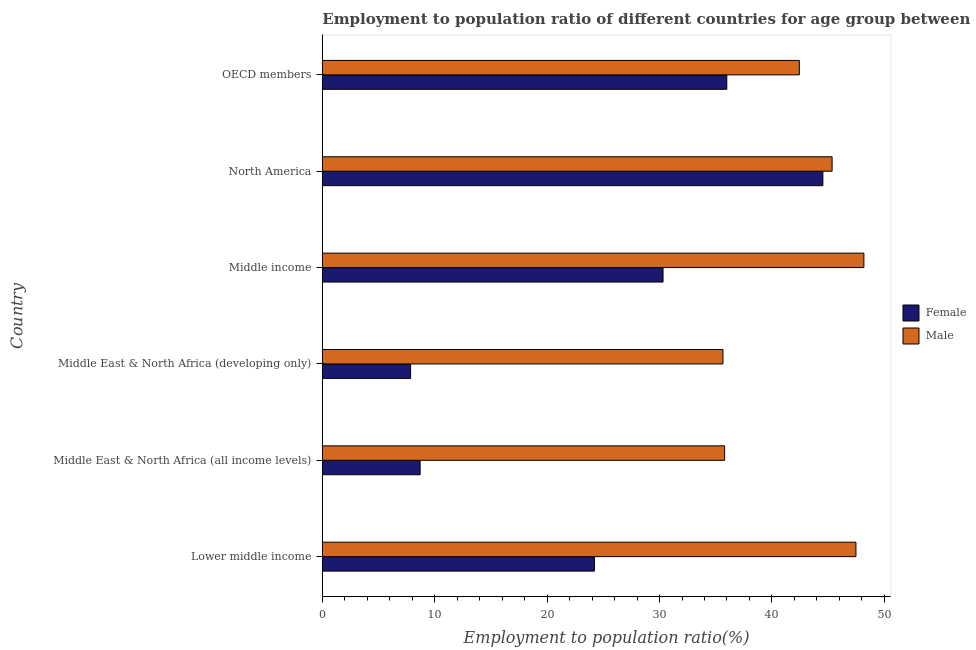How many different coloured bars are there?
Keep it short and to the point. 2. Are the number of bars per tick equal to the number of legend labels?
Offer a very short reply. Yes. Are the number of bars on each tick of the Y-axis equal?
Your response must be concise. Yes. How many bars are there on the 2nd tick from the top?
Offer a terse response. 2. How many bars are there on the 5th tick from the bottom?
Provide a succinct answer. 2. What is the label of the 3rd group of bars from the top?
Give a very brief answer. Middle income. What is the employment to population ratio(female) in Middle income?
Provide a succinct answer. 30.31. Across all countries, what is the maximum employment to population ratio(male)?
Offer a terse response. 48.18. Across all countries, what is the minimum employment to population ratio(male)?
Make the answer very short. 35.64. In which country was the employment to population ratio(male) minimum?
Your answer should be compact. Middle East & North Africa (developing only). What is the total employment to population ratio(female) in the graph?
Keep it short and to the point. 151.58. What is the difference between the employment to population ratio(male) in Lower middle income and that in Middle East & North Africa (developing only)?
Your answer should be compact. 11.83. What is the difference between the employment to population ratio(female) in OECD members and the employment to population ratio(male) in Lower middle income?
Ensure brevity in your answer.  -11.49. What is the average employment to population ratio(male) per country?
Provide a succinct answer. 42.48. What is the difference between the employment to population ratio(female) and employment to population ratio(male) in OECD members?
Offer a terse response. -6.45. What is the ratio of the employment to population ratio(male) in North America to that in OECD members?
Ensure brevity in your answer.  1.07. Is the difference between the employment to population ratio(male) in Middle East & North Africa (developing only) and Middle income greater than the difference between the employment to population ratio(female) in Middle East & North Africa (developing only) and Middle income?
Offer a very short reply. Yes. What is the difference between the highest and the second highest employment to population ratio(male)?
Offer a very short reply. 0.71. What is the difference between the highest and the lowest employment to population ratio(female)?
Keep it short and to the point. 36.68. In how many countries, is the employment to population ratio(female) greater than the average employment to population ratio(female) taken over all countries?
Provide a short and direct response. 3. Is the sum of the employment to population ratio(female) in Middle East & North Africa (all income levels) and Middle East & North Africa (developing only) greater than the maximum employment to population ratio(male) across all countries?
Provide a succinct answer. No. How many bars are there?
Give a very brief answer. 12. Are all the bars in the graph horizontal?
Your answer should be compact. Yes. How many countries are there in the graph?
Provide a short and direct response. 6. Are the values on the major ticks of X-axis written in scientific E-notation?
Ensure brevity in your answer.  No. Where does the legend appear in the graph?
Make the answer very short. Center right. How many legend labels are there?
Keep it short and to the point. 2. How are the legend labels stacked?
Provide a succinct answer. Vertical. What is the title of the graph?
Offer a very short reply. Employment to population ratio of different countries for age group between 15-24 years. Does "Broad money growth" appear as one of the legend labels in the graph?
Provide a short and direct response. No. What is the Employment to population ratio(%) in Female in Lower middle income?
Ensure brevity in your answer.  24.21. What is the Employment to population ratio(%) of Male in Lower middle income?
Your answer should be very brief. 47.47. What is the Employment to population ratio(%) in Female in Middle East & North Africa (all income levels)?
Give a very brief answer. 8.7. What is the Employment to population ratio(%) of Male in Middle East & North Africa (all income levels)?
Give a very brief answer. 35.79. What is the Employment to population ratio(%) of Female in Middle East & North Africa (developing only)?
Your response must be concise. 7.85. What is the Employment to population ratio(%) of Male in Middle East & North Africa (developing only)?
Provide a succinct answer. 35.64. What is the Employment to population ratio(%) of Female in Middle income?
Provide a succinct answer. 30.31. What is the Employment to population ratio(%) in Male in Middle income?
Ensure brevity in your answer.  48.18. What is the Employment to population ratio(%) of Female in North America?
Your answer should be compact. 44.53. What is the Employment to population ratio(%) in Male in North America?
Your answer should be very brief. 45.35. What is the Employment to population ratio(%) of Female in OECD members?
Offer a terse response. 35.98. What is the Employment to population ratio(%) of Male in OECD members?
Offer a terse response. 42.44. Across all countries, what is the maximum Employment to population ratio(%) in Female?
Ensure brevity in your answer.  44.53. Across all countries, what is the maximum Employment to population ratio(%) of Male?
Provide a short and direct response. 48.18. Across all countries, what is the minimum Employment to population ratio(%) of Female?
Ensure brevity in your answer.  7.85. Across all countries, what is the minimum Employment to population ratio(%) of Male?
Make the answer very short. 35.64. What is the total Employment to population ratio(%) of Female in the graph?
Offer a very short reply. 151.58. What is the total Employment to population ratio(%) in Male in the graph?
Provide a short and direct response. 254.87. What is the difference between the Employment to population ratio(%) of Female in Lower middle income and that in Middle East & North Africa (all income levels)?
Offer a very short reply. 15.51. What is the difference between the Employment to population ratio(%) in Male in Lower middle income and that in Middle East & North Africa (all income levels)?
Offer a terse response. 11.68. What is the difference between the Employment to population ratio(%) in Female in Lower middle income and that in Middle East & North Africa (developing only)?
Ensure brevity in your answer.  16.36. What is the difference between the Employment to population ratio(%) of Male in Lower middle income and that in Middle East & North Africa (developing only)?
Give a very brief answer. 11.83. What is the difference between the Employment to population ratio(%) of Female in Lower middle income and that in Middle income?
Ensure brevity in your answer.  -6.1. What is the difference between the Employment to population ratio(%) in Male in Lower middle income and that in Middle income?
Your answer should be compact. -0.71. What is the difference between the Employment to population ratio(%) in Female in Lower middle income and that in North America?
Offer a terse response. -20.32. What is the difference between the Employment to population ratio(%) of Male in Lower middle income and that in North America?
Keep it short and to the point. 2.12. What is the difference between the Employment to population ratio(%) of Female in Lower middle income and that in OECD members?
Keep it short and to the point. -11.78. What is the difference between the Employment to population ratio(%) in Male in Lower middle income and that in OECD members?
Provide a short and direct response. 5.04. What is the difference between the Employment to population ratio(%) of Female in Middle East & North Africa (all income levels) and that in Middle East & North Africa (developing only)?
Make the answer very short. 0.85. What is the difference between the Employment to population ratio(%) of Male in Middle East & North Africa (all income levels) and that in Middle East & North Africa (developing only)?
Make the answer very short. 0.15. What is the difference between the Employment to population ratio(%) in Female in Middle East & North Africa (all income levels) and that in Middle income?
Give a very brief answer. -21.61. What is the difference between the Employment to population ratio(%) in Male in Middle East & North Africa (all income levels) and that in Middle income?
Offer a terse response. -12.39. What is the difference between the Employment to population ratio(%) of Female in Middle East & North Africa (all income levels) and that in North America?
Provide a succinct answer. -35.83. What is the difference between the Employment to population ratio(%) of Male in Middle East & North Africa (all income levels) and that in North America?
Make the answer very short. -9.56. What is the difference between the Employment to population ratio(%) in Female in Middle East & North Africa (all income levels) and that in OECD members?
Offer a terse response. -27.28. What is the difference between the Employment to population ratio(%) of Male in Middle East & North Africa (all income levels) and that in OECD members?
Make the answer very short. -6.65. What is the difference between the Employment to population ratio(%) of Female in Middle East & North Africa (developing only) and that in Middle income?
Your answer should be compact. -22.46. What is the difference between the Employment to population ratio(%) in Male in Middle East & North Africa (developing only) and that in Middle income?
Your response must be concise. -12.54. What is the difference between the Employment to population ratio(%) in Female in Middle East & North Africa (developing only) and that in North America?
Ensure brevity in your answer.  -36.68. What is the difference between the Employment to population ratio(%) in Male in Middle East & North Africa (developing only) and that in North America?
Ensure brevity in your answer.  -9.71. What is the difference between the Employment to population ratio(%) in Female in Middle East & North Africa (developing only) and that in OECD members?
Provide a succinct answer. -28.13. What is the difference between the Employment to population ratio(%) in Male in Middle East & North Africa (developing only) and that in OECD members?
Your answer should be compact. -6.8. What is the difference between the Employment to population ratio(%) in Female in Middle income and that in North America?
Ensure brevity in your answer.  -14.22. What is the difference between the Employment to population ratio(%) of Male in Middle income and that in North America?
Ensure brevity in your answer.  2.83. What is the difference between the Employment to population ratio(%) of Female in Middle income and that in OECD members?
Give a very brief answer. -5.67. What is the difference between the Employment to population ratio(%) in Male in Middle income and that in OECD members?
Your answer should be very brief. 5.74. What is the difference between the Employment to population ratio(%) in Female in North America and that in OECD members?
Offer a very short reply. 8.55. What is the difference between the Employment to population ratio(%) of Male in North America and that in OECD members?
Make the answer very short. 2.92. What is the difference between the Employment to population ratio(%) in Female in Lower middle income and the Employment to population ratio(%) in Male in Middle East & North Africa (all income levels)?
Make the answer very short. -11.58. What is the difference between the Employment to population ratio(%) in Female in Lower middle income and the Employment to population ratio(%) in Male in Middle East & North Africa (developing only)?
Your answer should be compact. -11.43. What is the difference between the Employment to population ratio(%) in Female in Lower middle income and the Employment to population ratio(%) in Male in Middle income?
Provide a succinct answer. -23.97. What is the difference between the Employment to population ratio(%) in Female in Lower middle income and the Employment to population ratio(%) in Male in North America?
Your response must be concise. -21.14. What is the difference between the Employment to population ratio(%) of Female in Lower middle income and the Employment to population ratio(%) of Male in OECD members?
Your answer should be compact. -18.23. What is the difference between the Employment to population ratio(%) of Female in Middle East & North Africa (all income levels) and the Employment to population ratio(%) of Male in Middle East & North Africa (developing only)?
Your answer should be very brief. -26.94. What is the difference between the Employment to population ratio(%) of Female in Middle East & North Africa (all income levels) and the Employment to population ratio(%) of Male in Middle income?
Provide a short and direct response. -39.48. What is the difference between the Employment to population ratio(%) in Female in Middle East & North Africa (all income levels) and the Employment to population ratio(%) in Male in North America?
Your response must be concise. -36.65. What is the difference between the Employment to population ratio(%) in Female in Middle East & North Africa (all income levels) and the Employment to population ratio(%) in Male in OECD members?
Make the answer very short. -33.74. What is the difference between the Employment to population ratio(%) of Female in Middle East & North Africa (developing only) and the Employment to population ratio(%) of Male in Middle income?
Your response must be concise. -40.33. What is the difference between the Employment to population ratio(%) in Female in Middle East & North Africa (developing only) and the Employment to population ratio(%) in Male in North America?
Provide a short and direct response. -37.5. What is the difference between the Employment to population ratio(%) in Female in Middle East & North Africa (developing only) and the Employment to population ratio(%) in Male in OECD members?
Ensure brevity in your answer.  -34.59. What is the difference between the Employment to population ratio(%) in Female in Middle income and the Employment to population ratio(%) in Male in North America?
Keep it short and to the point. -15.04. What is the difference between the Employment to population ratio(%) of Female in Middle income and the Employment to population ratio(%) of Male in OECD members?
Provide a short and direct response. -12.12. What is the difference between the Employment to population ratio(%) in Female in North America and the Employment to population ratio(%) in Male in OECD members?
Provide a short and direct response. 2.09. What is the average Employment to population ratio(%) in Female per country?
Ensure brevity in your answer.  25.26. What is the average Employment to population ratio(%) of Male per country?
Your response must be concise. 42.48. What is the difference between the Employment to population ratio(%) of Female and Employment to population ratio(%) of Male in Lower middle income?
Provide a succinct answer. -23.26. What is the difference between the Employment to population ratio(%) of Female and Employment to population ratio(%) of Male in Middle East & North Africa (all income levels)?
Provide a short and direct response. -27.09. What is the difference between the Employment to population ratio(%) of Female and Employment to population ratio(%) of Male in Middle East & North Africa (developing only)?
Ensure brevity in your answer.  -27.79. What is the difference between the Employment to population ratio(%) in Female and Employment to population ratio(%) in Male in Middle income?
Your answer should be very brief. -17.87. What is the difference between the Employment to population ratio(%) in Female and Employment to population ratio(%) in Male in North America?
Give a very brief answer. -0.82. What is the difference between the Employment to population ratio(%) of Female and Employment to population ratio(%) of Male in OECD members?
Ensure brevity in your answer.  -6.45. What is the ratio of the Employment to population ratio(%) in Female in Lower middle income to that in Middle East & North Africa (all income levels)?
Offer a terse response. 2.78. What is the ratio of the Employment to population ratio(%) of Male in Lower middle income to that in Middle East & North Africa (all income levels)?
Keep it short and to the point. 1.33. What is the ratio of the Employment to population ratio(%) of Female in Lower middle income to that in Middle East & North Africa (developing only)?
Provide a short and direct response. 3.08. What is the ratio of the Employment to population ratio(%) in Male in Lower middle income to that in Middle East & North Africa (developing only)?
Provide a succinct answer. 1.33. What is the ratio of the Employment to population ratio(%) in Female in Lower middle income to that in Middle income?
Offer a terse response. 0.8. What is the ratio of the Employment to population ratio(%) in Female in Lower middle income to that in North America?
Your answer should be compact. 0.54. What is the ratio of the Employment to population ratio(%) of Male in Lower middle income to that in North America?
Your answer should be very brief. 1.05. What is the ratio of the Employment to population ratio(%) in Female in Lower middle income to that in OECD members?
Provide a succinct answer. 0.67. What is the ratio of the Employment to population ratio(%) of Male in Lower middle income to that in OECD members?
Provide a short and direct response. 1.12. What is the ratio of the Employment to population ratio(%) of Female in Middle East & North Africa (all income levels) to that in Middle East & North Africa (developing only)?
Make the answer very short. 1.11. What is the ratio of the Employment to population ratio(%) of Male in Middle East & North Africa (all income levels) to that in Middle East & North Africa (developing only)?
Provide a short and direct response. 1. What is the ratio of the Employment to population ratio(%) of Female in Middle East & North Africa (all income levels) to that in Middle income?
Give a very brief answer. 0.29. What is the ratio of the Employment to population ratio(%) of Male in Middle East & North Africa (all income levels) to that in Middle income?
Provide a succinct answer. 0.74. What is the ratio of the Employment to population ratio(%) in Female in Middle East & North Africa (all income levels) to that in North America?
Offer a very short reply. 0.2. What is the ratio of the Employment to population ratio(%) in Male in Middle East & North Africa (all income levels) to that in North America?
Your answer should be compact. 0.79. What is the ratio of the Employment to population ratio(%) of Female in Middle East & North Africa (all income levels) to that in OECD members?
Provide a short and direct response. 0.24. What is the ratio of the Employment to population ratio(%) in Male in Middle East & North Africa (all income levels) to that in OECD members?
Provide a succinct answer. 0.84. What is the ratio of the Employment to population ratio(%) in Female in Middle East & North Africa (developing only) to that in Middle income?
Ensure brevity in your answer.  0.26. What is the ratio of the Employment to population ratio(%) of Male in Middle East & North Africa (developing only) to that in Middle income?
Offer a terse response. 0.74. What is the ratio of the Employment to population ratio(%) of Female in Middle East & North Africa (developing only) to that in North America?
Provide a succinct answer. 0.18. What is the ratio of the Employment to population ratio(%) in Male in Middle East & North Africa (developing only) to that in North America?
Offer a very short reply. 0.79. What is the ratio of the Employment to population ratio(%) in Female in Middle East & North Africa (developing only) to that in OECD members?
Provide a short and direct response. 0.22. What is the ratio of the Employment to population ratio(%) in Male in Middle East & North Africa (developing only) to that in OECD members?
Provide a short and direct response. 0.84. What is the ratio of the Employment to population ratio(%) in Female in Middle income to that in North America?
Provide a short and direct response. 0.68. What is the ratio of the Employment to population ratio(%) in Male in Middle income to that in North America?
Give a very brief answer. 1.06. What is the ratio of the Employment to population ratio(%) in Female in Middle income to that in OECD members?
Your answer should be compact. 0.84. What is the ratio of the Employment to population ratio(%) in Male in Middle income to that in OECD members?
Provide a short and direct response. 1.14. What is the ratio of the Employment to population ratio(%) in Female in North America to that in OECD members?
Provide a short and direct response. 1.24. What is the ratio of the Employment to population ratio(%) in Male in North America to that in OECD members?
Provide a succinct answer. 1.07. What is the difference between the highest and the second highest Employment to population ratio(%) in Female?
Provide a short and direct response. 8.55. What is the difference between the highest and the second highest Employment to population ratio(%) of Male?
Your answer should be compact. 0.71. What is the difference between the highest and the lowest Employment to population ratio(%) in Female?
Provide a short and direct response. 36.68. What is the difference between the highest and the lowest Employment to population ratio(%) in Male?
Ensure brevity in your answer.  12.54. 